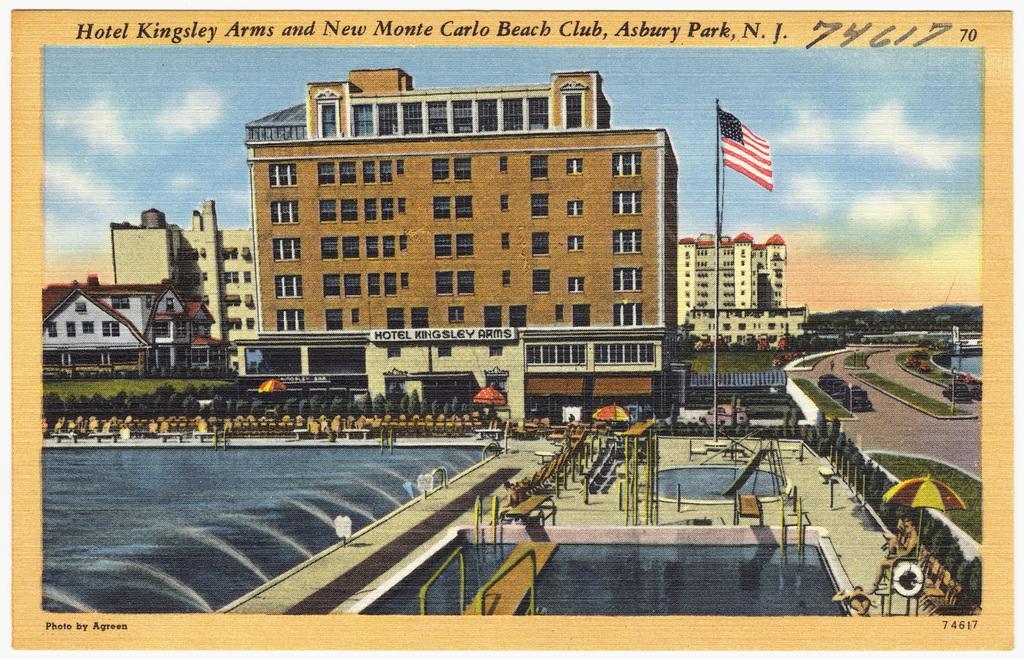Can you describe this image briefly? In this image there are so many buildings, in-front of that there is a park, swimming pool, fountain and pole with flag, also there are some trees and road beside the building. 